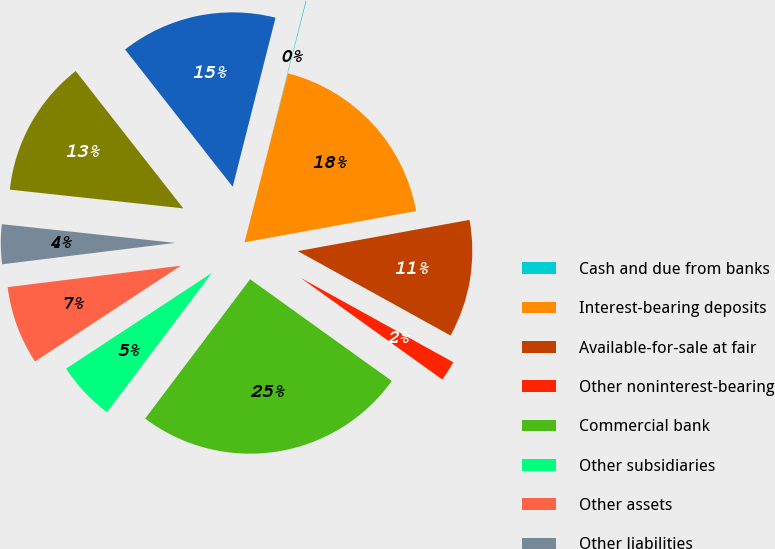<chart> <loc_0><loc_0><loc_500><loc_500><pie_chart><fcel>Cash and due from banks<fcel>Interest-bearing deposits<fcel>Available-for-sale at fair<fcel>Other noninterest-bearing<fcel>Commercial bank<fcel>Other subsidiaries<fcel>Other assets<fcel>Other liabilities<fcel>Subordinated debt to<fcel>Due to others<nl><fcel>0.06%<fcel>18.13%<fcel>10.9%<fcel>1.87%<fcel>25.36%<fcel>5.48%<fcel>7.29%<fcel>3.67%<fcel>12.71%<fcel>14.52%<nl></chart> 